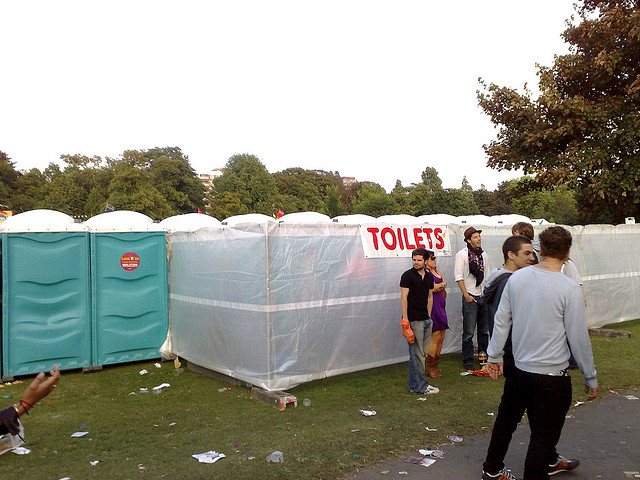Identify the text displayed in this image. TOILETS 